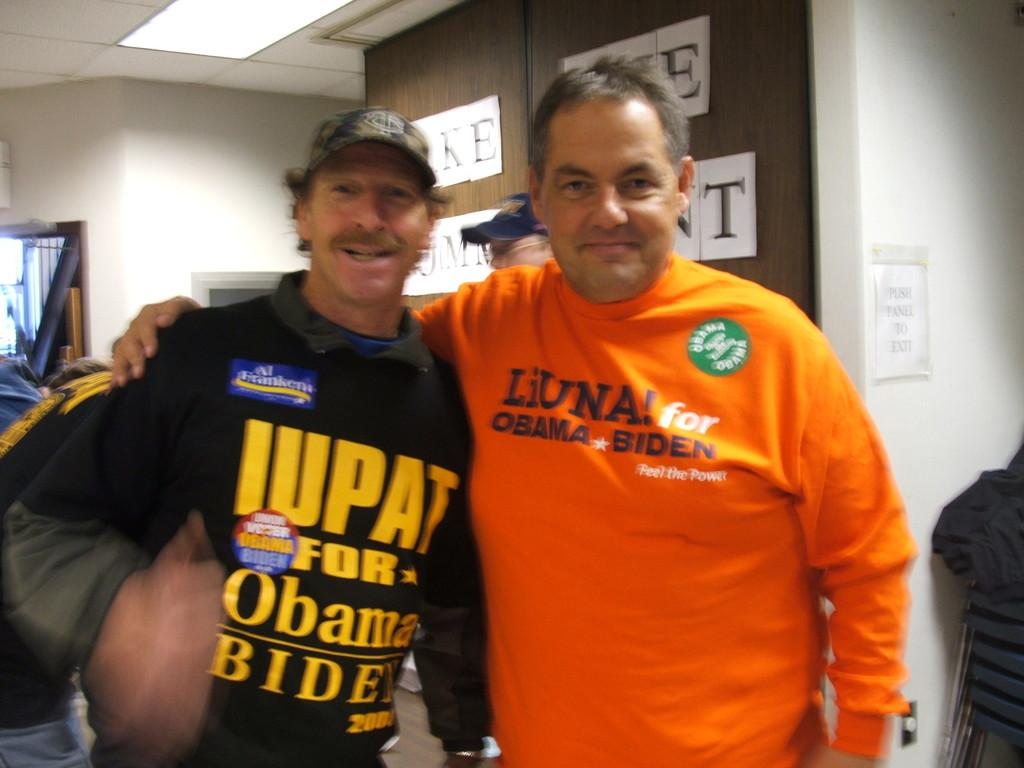<image>
Offer a succinct explanation of the picture presented. a man wearing a shirt that says 'liuna! for obama biden!' on it 